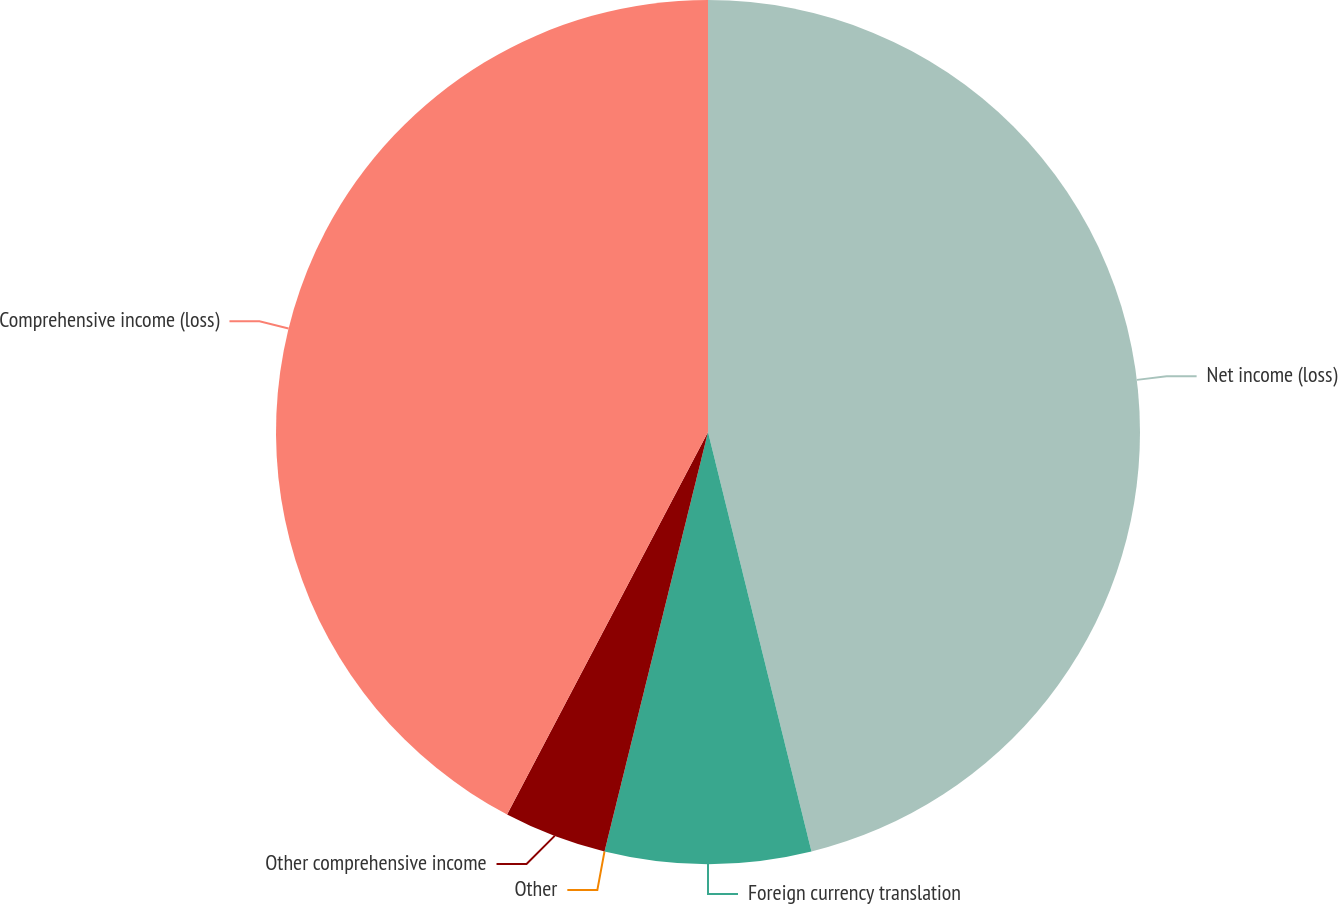<chart> <loc_0><loc_0><loc_500><loc_500><pie_chart><fcel>Net income (loss)<fcel>Foreign currency translation<fcel>Other<fcel>Other comprehensive income<fcel>Comprehensive income (loss)<nl><fcel>46.15%<fcel>7.7%<fcel>0.0%<fcel>3.85%<fcel>42.3%<nl></chart> 